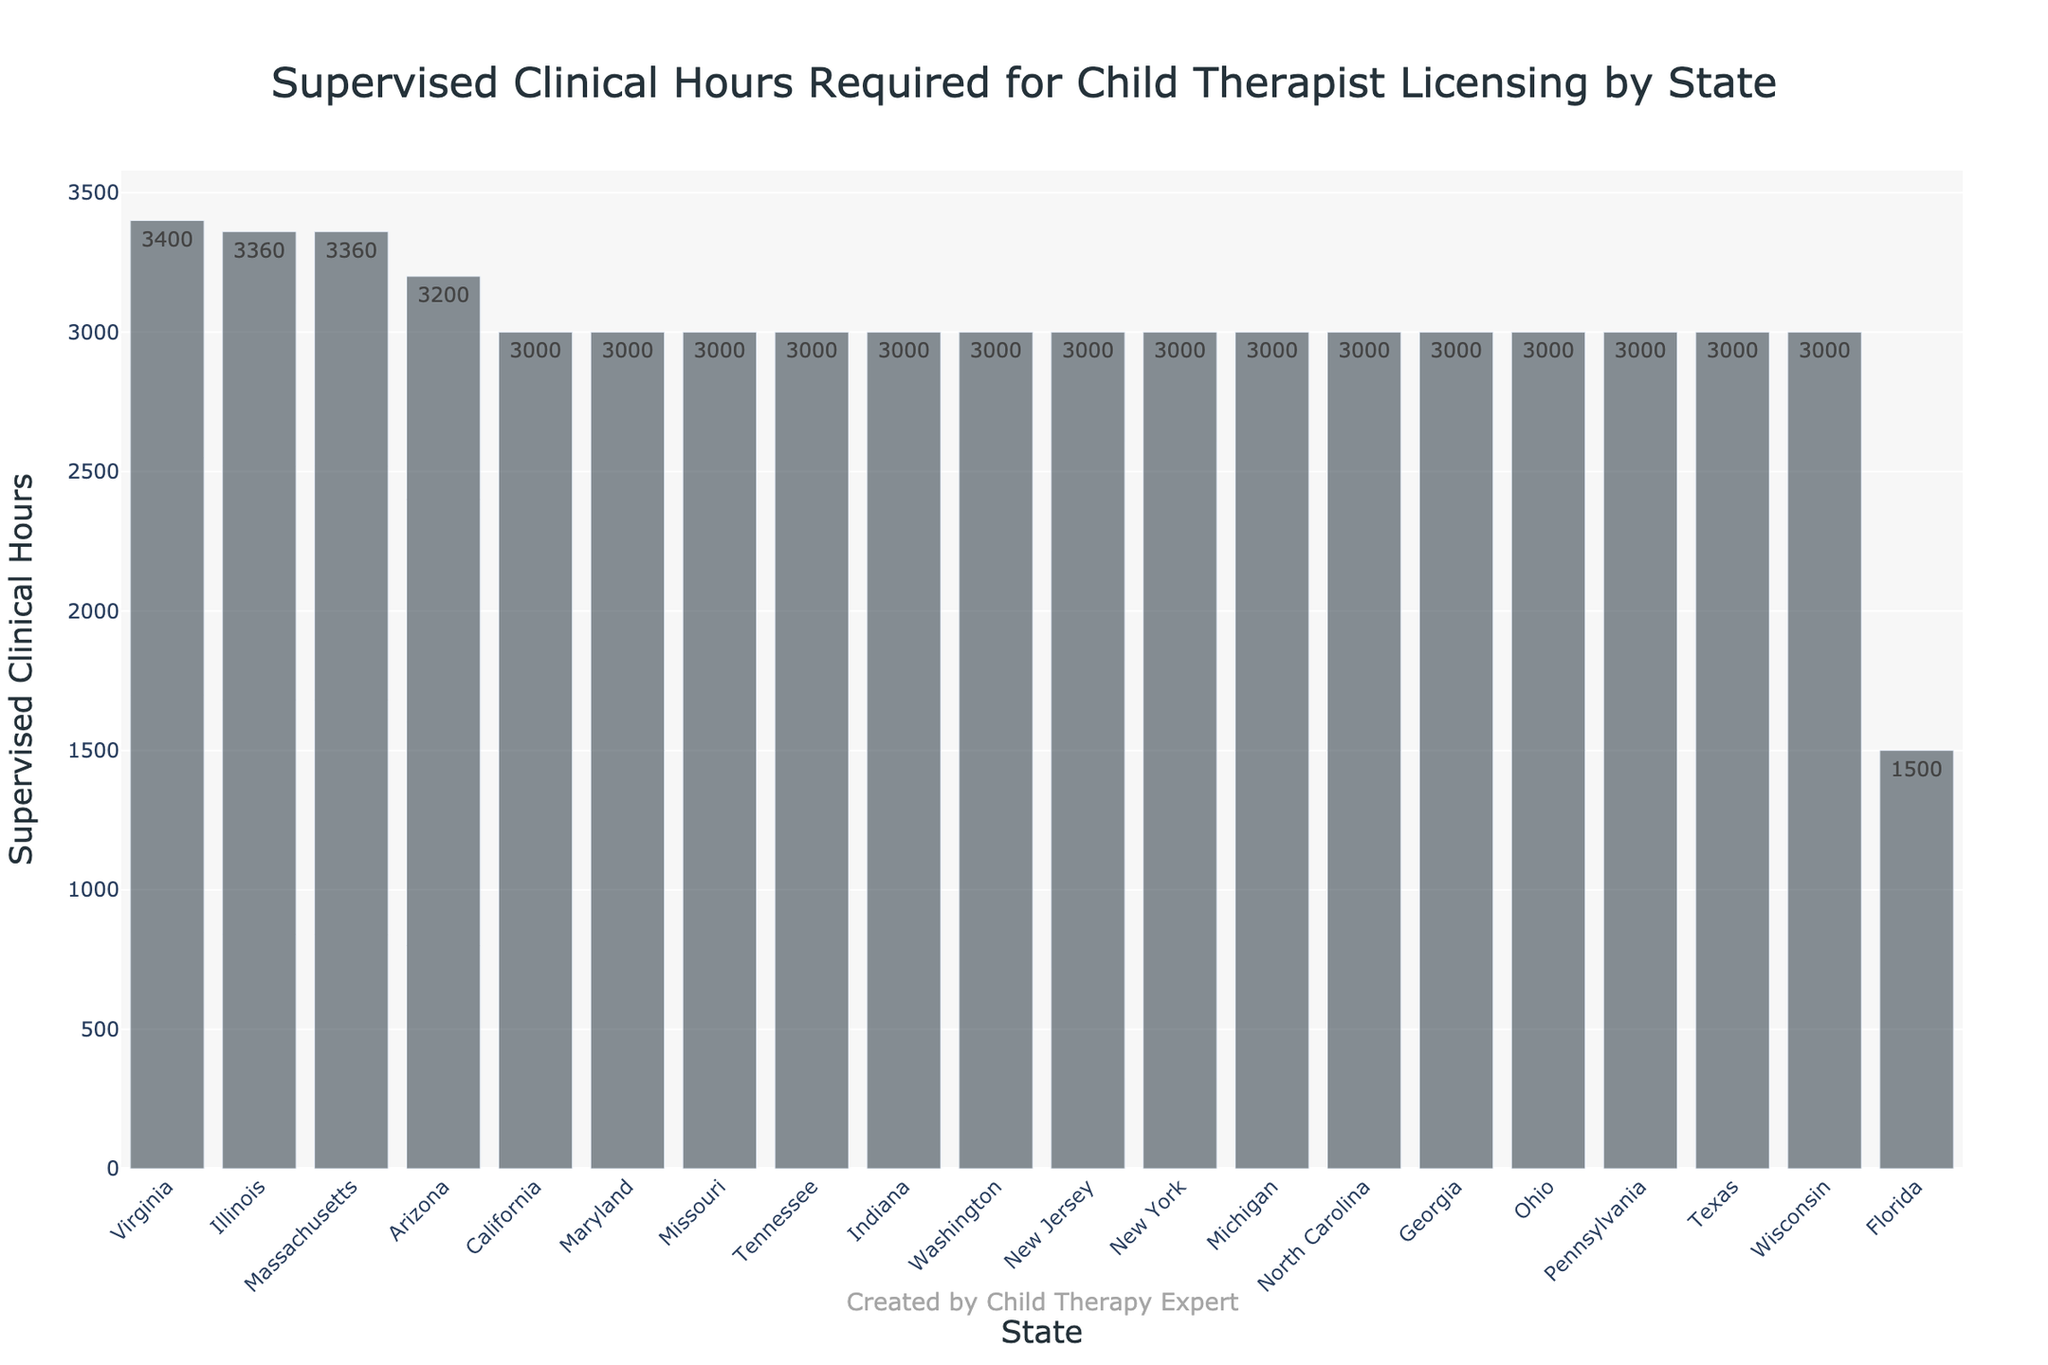Which state requires the most supervised clinical hours? By looking at the bar chart, we can see that Virginia has the highest bar. The hover text shows that Virginia requires 3400 supervised clinical hours.
Answer: Virginia Which states have the same requirement for supervised clinical hours? Observe the height of the bars and the hover text. Several states, including California, New York, Texas, Pennsylvania, Ohio, Georgia, North Carolina, and others require 3000 supervised clinical hours.
Answer: California, New York, Texas, Pennsylvania, Ohio, Georgia, North Carolina, and others How many states require exactly 3000 supervised clinical hours? Count the number of bars that reach the level of 3000 supervised clinical hours. There are 13 states with this requirement.
Answer: 13 Compare the supervised clinical hours required in California and Florida. Compare the heights of the bars for California and Florida. The hover text shows California requires 3000 hours, while Florida requires 1500 hours. The difference is 3000 - 1500 = 1500.
Answer: California requires 1500 more hours than Florida What is the total number of supervised clinical hours required by the states with the top 3 highest requirements? Identify the top 3 bars, which belong to Virginia (3400), Illinois (3360), and Massachusetts (3360). Sum these values: 3400 + 3360 + 3360 = 10120.
Answer: 10120 Which state requires the least number of supervised clinical hours? By observing the shortest bar, we see that Florida requires the least, at 1500 hours.
Answer: Florida What is the average number of supervised clinical hours required across all states? Add up all the supervised clinical hours and divide by the number of states. The sum is 51920 and there are 19 states, so the average is 51920 / 19 ≈ 2733.68.
Answer: 2733.68 Compare the annual continuing education hours required for New Jersey and Michigan. Which state requires more? The hover text shows that New Jersey requires 40 hours, whereas Michigan requires 45 hours. Michigan requires 5 more hours than New Jersey.
Answer: Michigan 